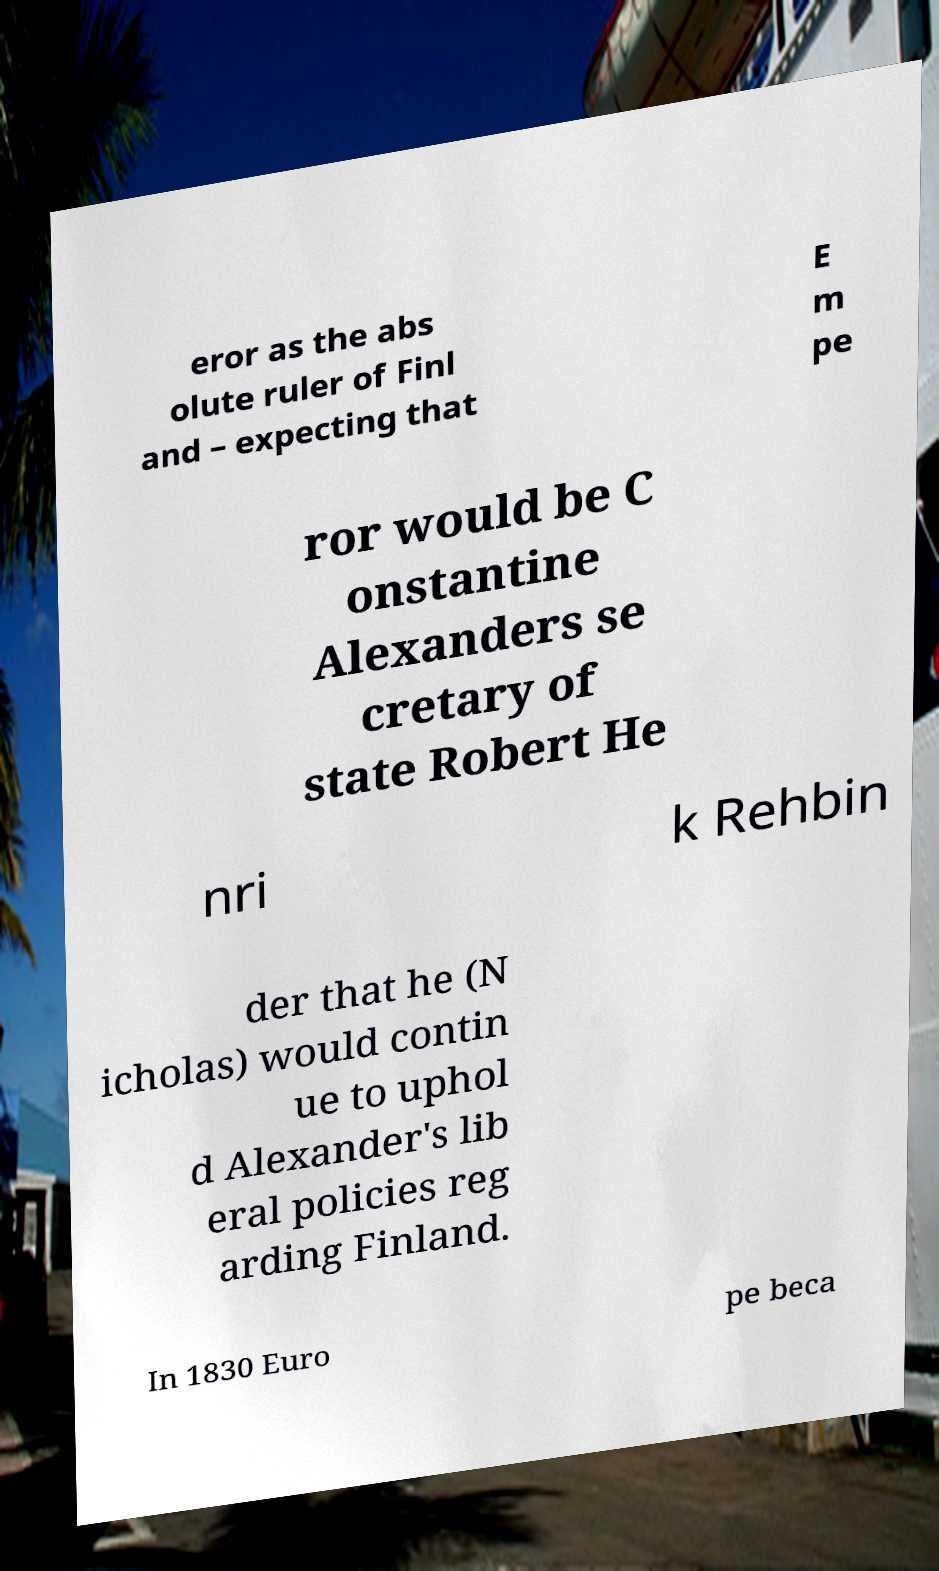Could you assist in decoding the text presented in this image and type it out clearly? eror as the abs olute ruler of Finl and – expecting that E m pe ror would be C onstantine Alexanders se cretary of state Robert He nri k Rehbin der that he (N icholas) would contin ue to uphol d Alexander's lib eral policies reg arding Finland. In 1830 Euro pe beca 